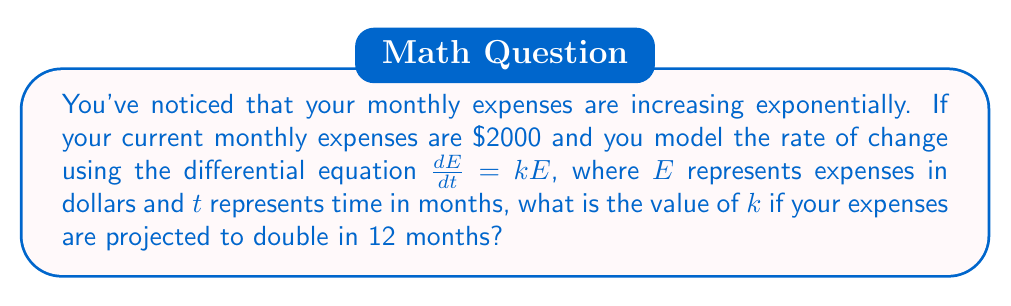Can you solve this math problem? Let's approach this step-by-step:

1) The given differential equation is $\frac{dE}{dt} = kE$, which represents exponential growth.

2) The solution to this differential equation is:
   $E(t) = E_0 e^{kt}$
   where $E_0$ is the initial expense.

3) We know that:
   - Initial expense, $E_0 = 2000$
   - At $t = 12$ months, the expense doubles, so $E(12) = 2E_0 = 4000$

4) Let's substitute these into our solution equation:
   $4000 = 2000 e^{12k}$

5) Simplify:
   $2 = e^{12k}$

6) Take the natural log of both sides:
   $\ln(2) = 12k$

7) Solve for $k$:
   $k = \frac{\ln(2)}{12}$

8) Calculate the value:
   $k \approx 0.0578$ (rounded to 4 decimal places)

This means the expenses are increasing at a rate of about 5.78% per month.
Answer: $k = \frac{\ln(2)}{12} \approx 0.0578$ 